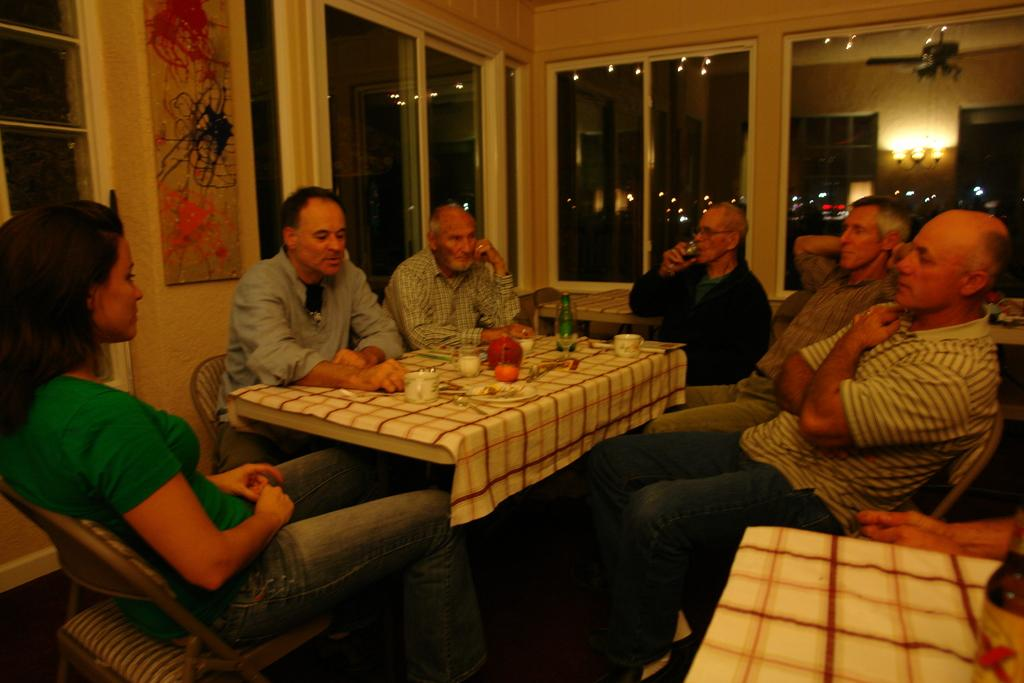What are the people in the image doing? The people in the image are sitting around a table. What is on the table in the image? There is a cloth on the table and food stuff. What type of hat is the person wearing in the image? There is no person wearing a hat in the image. What is the person writing on the table in the image? There is no person writing on the table in the image. 